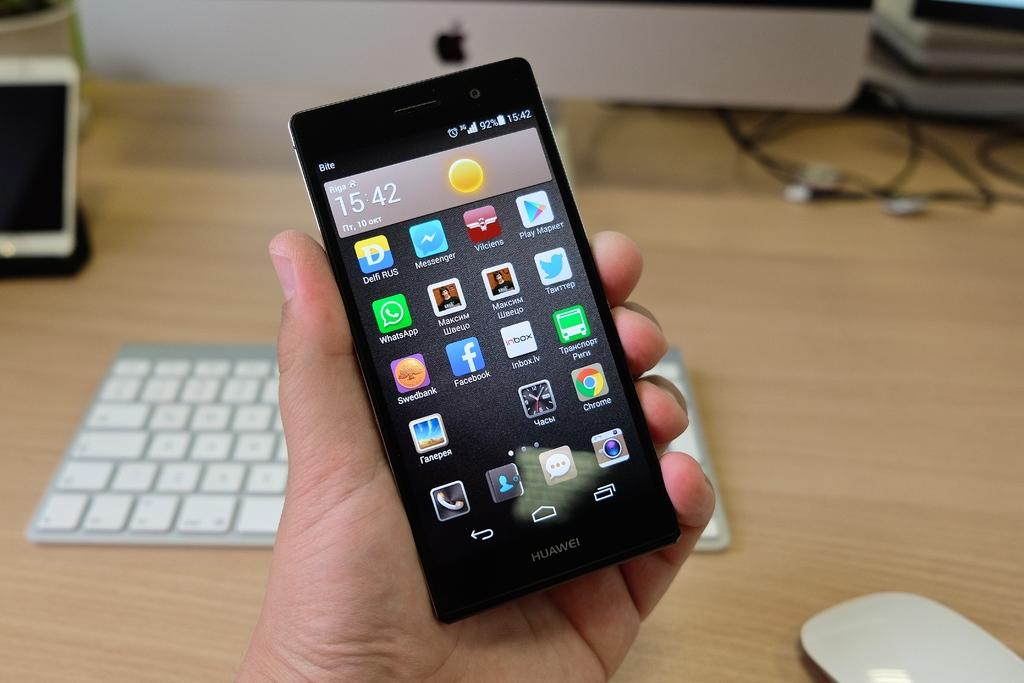<image>
Summarize the visual content of the image. A hand is holding up a Huawei smartphone in front of a wooden desk top. 